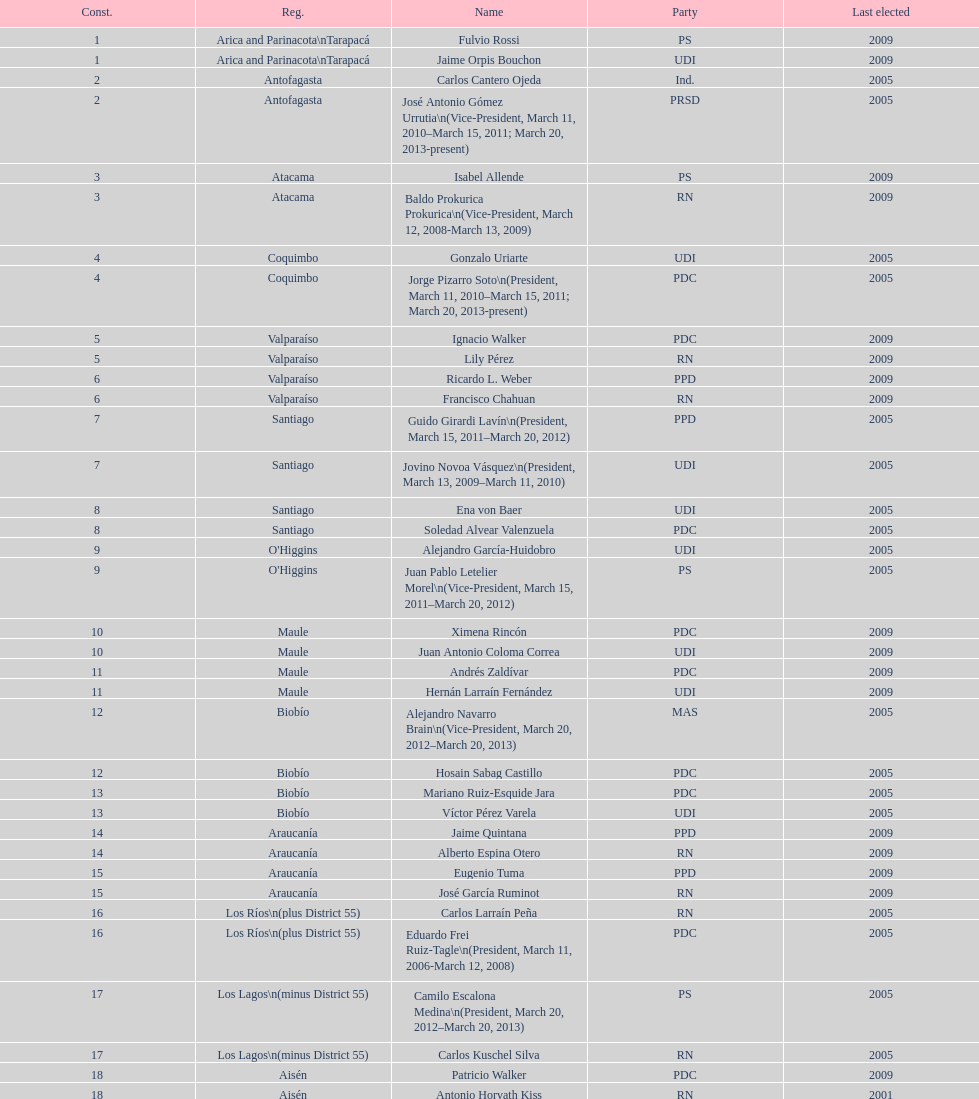How long was baldo prokurica prokurica vice-president? 1 year. 